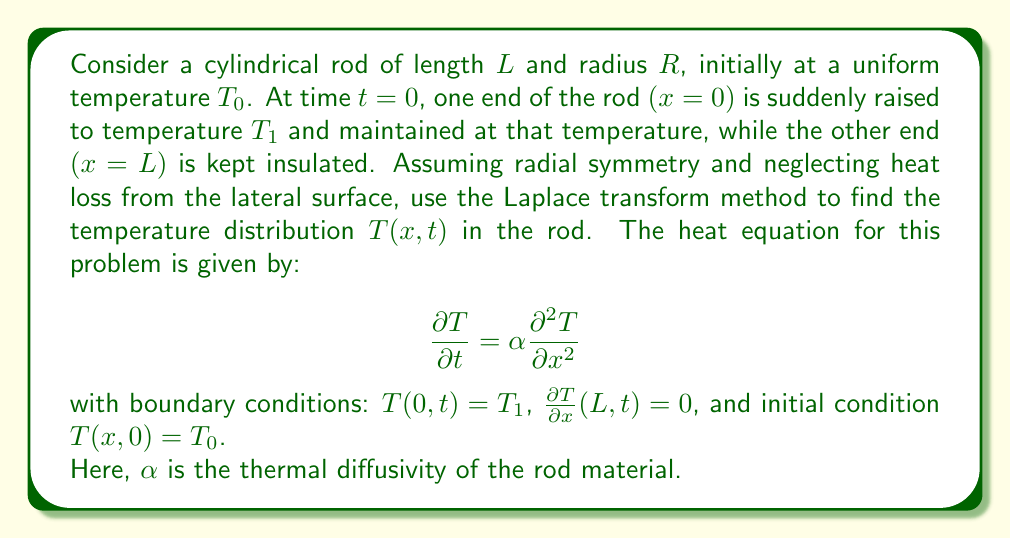Could you help me with this problem? Let's solve this problem step by step using the Laplace transform method:

1) First, we define $u(x,t) = T(x,t) - T_0$. This transforms our problem into:

   $$\frac{\partial u}{\partial t} = \alpha \frac{\partial^2 u}{\partial x^2}$$

   with boundary conditions: $u(0,t) = T_1 - T_0$, $\frac{\partial u}{\partial x}(L,t) = 0$, and initial condition $u(x,0) = 0$.

2) Now, let's apply the Laplace transform with respect to $t$. Let $U(x,s)$ be the Laplace transform of $u(x,t)$. We get:

   $$sU(x,s) - u(x,0) = \alpha \frac{d^2U}{dx^2}$$

   $$sU(x,s) = \alpha \frac{d^2U}{dx^2}$$

3) The boundary conditions in the $s$-domain become:
   $U(0,s) = \frac{T_1 - T_0}{s}$ and $\frac{dU}{dx}(L,s) = 0$

4) The general solution to this ODE is:

   $$U(x,s) = A \cosh(\sqrt{\frac{s}{\alpha}}x) + B \sinh(\sqrt{\frac{s}{\alpha}}x)$$

5) Applying the boundary conditions:

   At $x=0$: $U(0,s) = A = \frac{T_1 - T_0}{s}$

   At $x=L$: $\frac{dU}{dx}(L,s) = A\sqrt{\frac{s}{\alpha}} \sinh(\sqrt{\frac{s}{\alpha}}L) + B\sqrt{\frac{s}{\alpha}} \cosh(\sqrt{\frac{s}{\alpha}}L) = 0$

   From this, we can find $B$:

   $$B = -A \tanh(\sqrt{\frac{s}{\alpha}}L) = -\frac{T_1 - T_0}{s} \tanh(\sqrt{\frac{s}{\alpha}}L)$$

6) Therefore, our solution in the $s$-domain is:

   $$U(x,s) = \frac{T_1 - T_0}{s} \left[\cosh(\sqrt{\frac{s}{\alpha}}x) - \tanh(\sqrt{\frac{s}{\alpha}}L) \sinh(\sqrt{\frac{s}{\alpha}}x)\right]$$

7) To find $u(x,t)$, we need to take the inverse Laplace transform. This is a complex step involving contour integration and residue theorem. The result is:

   $$u(x,t) = (T_1 - T_0) \left[1 - \frac{4}{\pi} \sum_{n=0}^{\infty} \frac{(-1)^n}{2n+1} \cos\left(\frac{(2n+1)\pi x}{2L}\right) e^{-\alpha\left(\frac{(2n+1)\pi}{2L}\right)^2 t}\right]$$

8) Finally, we can write the solution for $T(x,t)$:

   $$T(x,t) = T_0 + (T_1 - T_0) \left[1 - \frac{4}{\pi} \sum_{n=0}^{\infty} \frac{(-1)^n}{2n+1} \cos\left(\frac{(2n+1)\pi x}{2L}\right) e^{-\alpha\left(\frac{(2n+1)\pi}{2L}\right)^2 t}\right]$$

This solution represents the temperature distribution in the rod as a function of position $x$ and time $t$.
Answer: $$T(x,t) = T_0 + (T_1 - T_0) \left[1 - \frac{4}{\pi} \sum_{n=0}^{\infty} \frac{(-1)^n}{2n+1} \cos\left(\frac{(2n+1)\pi x}{2L}\right) e^{-\alpha\left(\frac{(2n+1)\pi}{2L}\right)^2 t}\right]$$ 